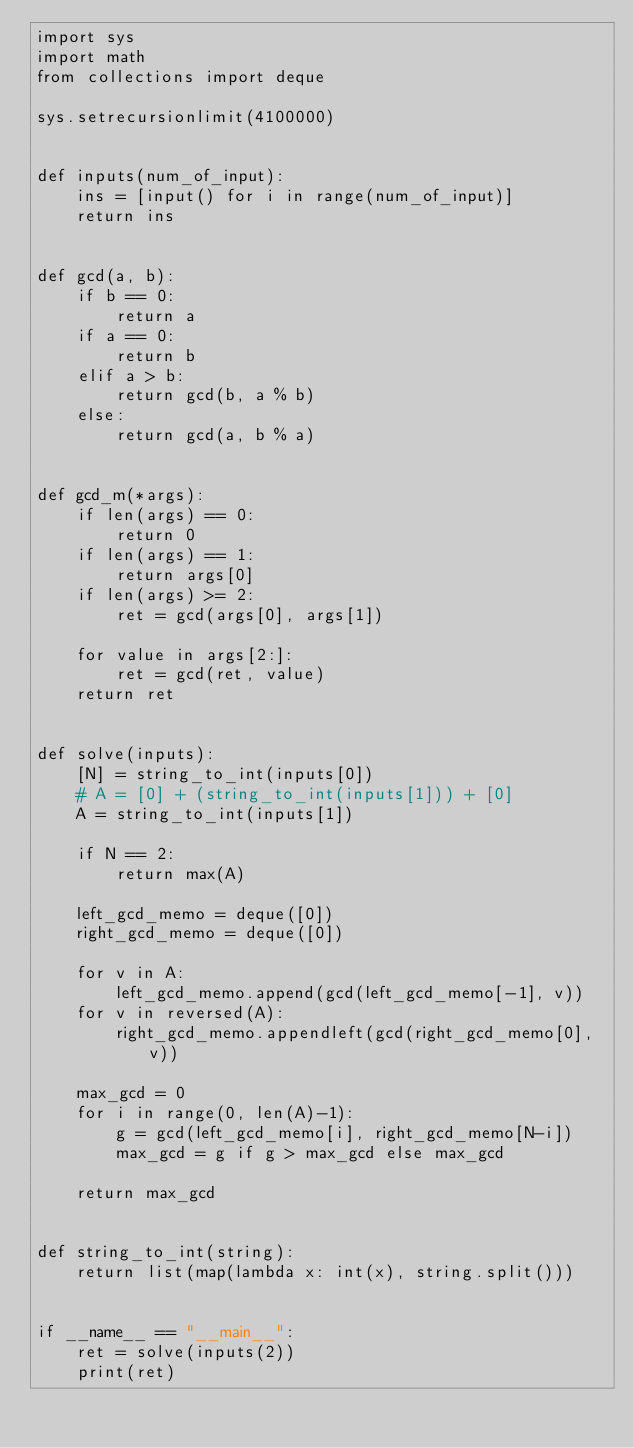Convert code to text. <code><loc_0><loc_0><loc_500><loc_500><_Python_>import sys
import math
from collections import deque

sys.setrecursionlimit(4100000)


def inputs(num_of_input):
    ins = [input() for i in range(num_of_input)]
    return ins


def gcd(a, b):
    if b == 0:
        return a
    if a == 0:
        return b
    elif a > b:
        return gcd(b, a % b)
    else:
        return gcd(a, b % a)


def gcd_m(*args):
    if len(args) == 0:
        return 0
    if len(args) == 1:
        return args[0]
    if len(args) >= 2:
        ret = gcd(args[0], args[1])

    for value in args[2:]:
        ret = gcd(ret, value)
    return ret


def solve(inputs):
    [N] = string_to_int(inputs[0])
    # A = [0] + (string_to_int(inputs[1])) + [0]
    A = string_to_int(inputs[1])

    if N == 2:
        return max(A)

    left_gcd_memo = deque([0])
    right_gcd_memo = deque([0])

    for v in A:
        left_gcd_memo.append(gcd(left_gcd_memo[-1], v))
    for v in reversed(A):
        right_gcd_memo.appendleft(gcd(right_gcd_memo[0], v))

    max_gcd = 0
    for i in range(0, len(A)-1):
        g = gcd(left_gcd_memo[i], right_gcd_memo[N-i])
        max_gcd = g if g > max_gcd else max_gcd

    return max_gcd


def string_to_int(string):
    return list(map(lambda x: int(x), string.split()))


if __name__ == "__main__":
    ret = solve(inputs(2))
    print(ret)
</code> 